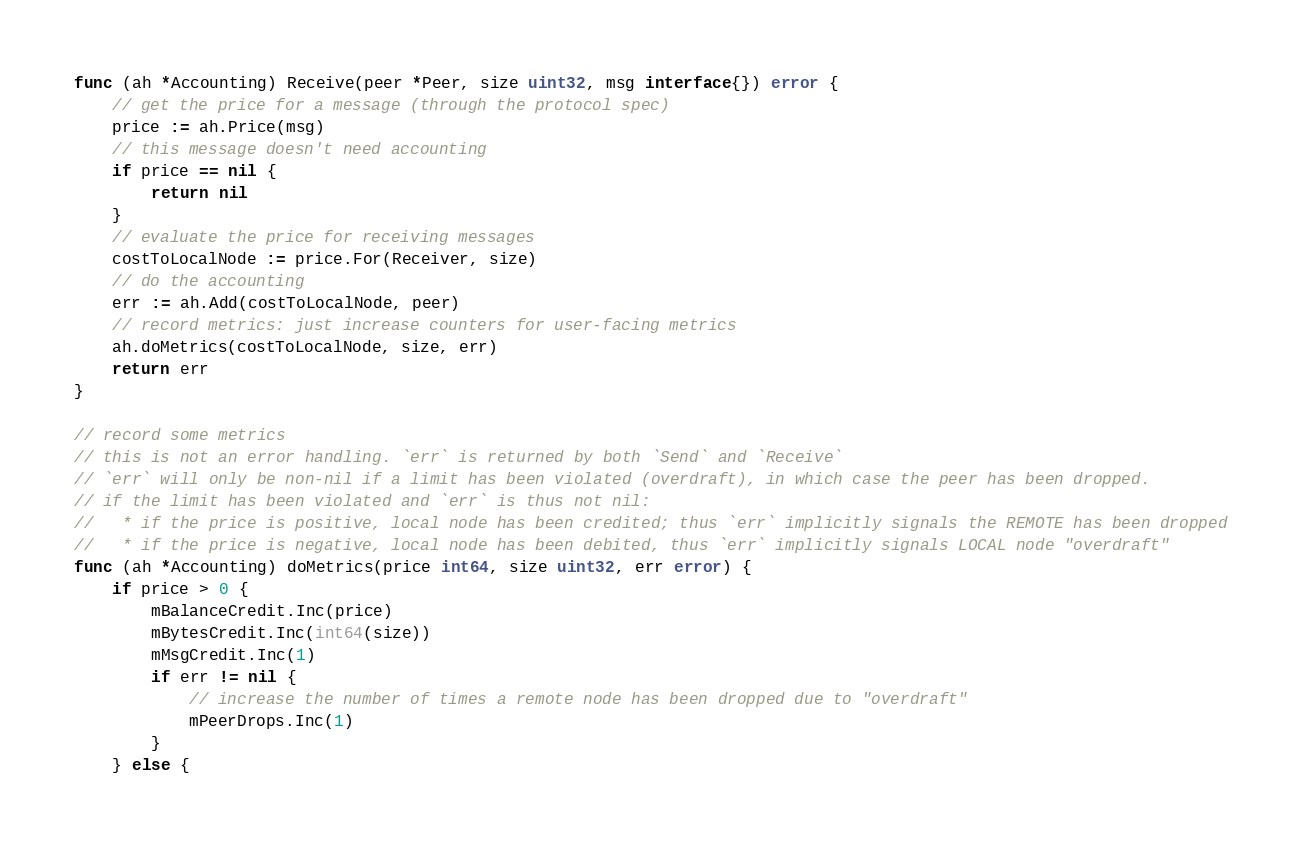Convert code to text. <code><loc_0><loc_0><loc_500><loc_500><_Go_>func (ah *Accounting) Receive(peer *Peer, size uint32, msg interface{}) error {
	// get the price for a message (through the protocol spec)
	price := ah.Price(msg)
	// this message doesn't need accounting
	if price == nil {
		return nil
	}
	// evaluate the price for receiving messages
	costToLocalNode := price.For(Receiver, size)
	// do the accounting
	err := ah.Add(costToLocalNode, peer)
	// record metrics: just increase counters for user-facing metrics
	ah.doMetrics(costToLocalNode, size, err)
	return err
}

// record some metrics
// this is not an error handling. `err` is returned by both `Send` and `Receive`
// `err` will only be non-nil if a limit has been violated (overdraft), in which case the peer has been dropped.
// if the limit has been violated and `err` is thus not nil:
//   * if the price is positive, local node has been credited; thus `err` implicitly signals the REMOTE has been dropped
//   * if the price is negative, local node has been debited, thus `err` implicitly signals LOCAL node "overdraft"
func (ah *Accounting) doMetrics(price int64, size uint32, err error) {
	if price > 0 {
		mBalanceCredit.Inc(price)
		mBytesCredit.Inc(int64(size))
		mMsgCredit.Inc(1)
		if err != nil {
			// increase the number of times a remote node has been dropped due to "overdraft"
			mPeerDrops.Inc(1)
		}
	} else {</code> 